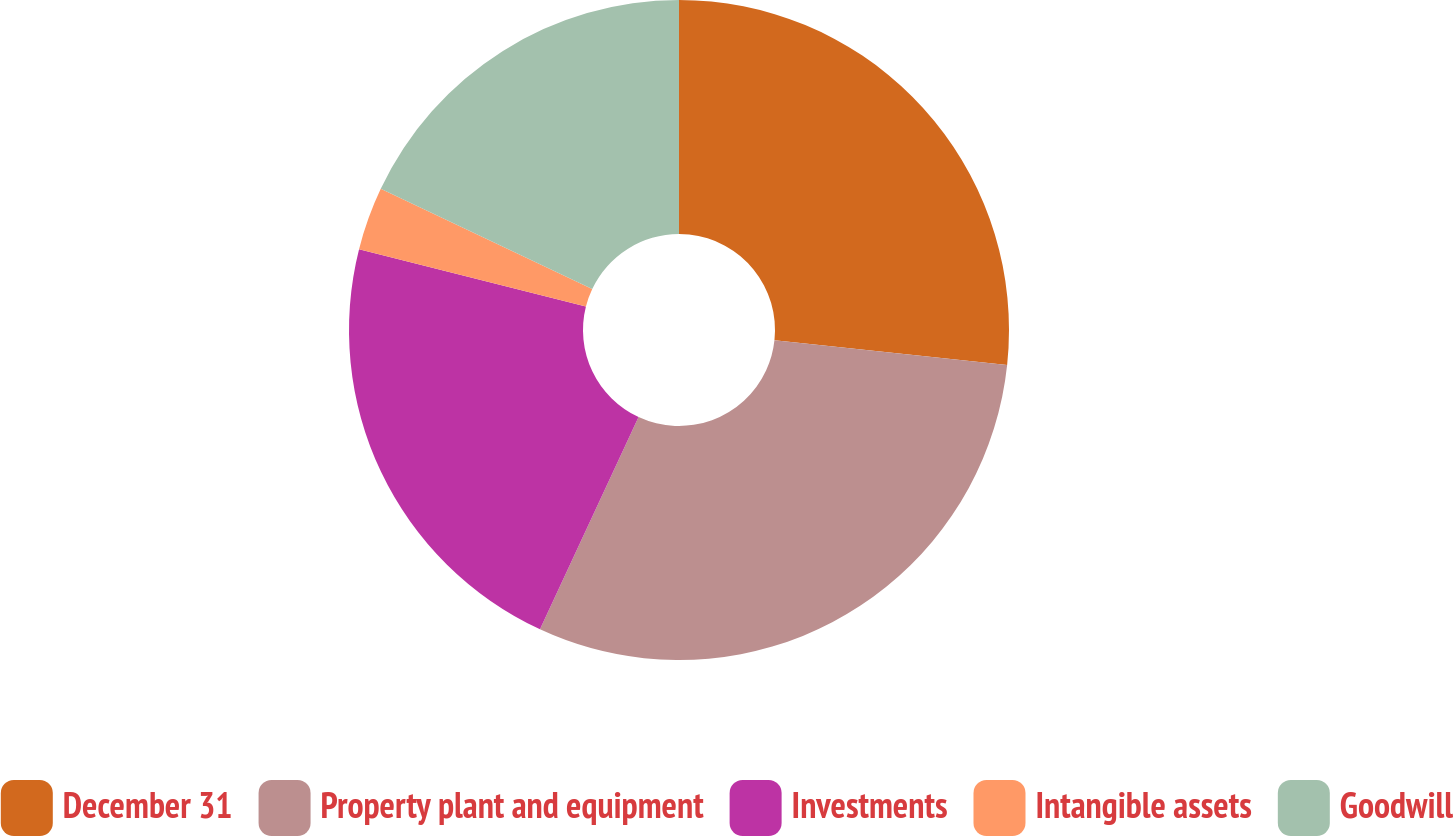Convert chart to OTSL. <chart><loc_0><loc_0><loc_500><loc_500><pie_chart><fcel>December 31<fcel>Property plant and equipment<fcel>Investments<fcel>Intangible assets<fcel>Goodwill<nl><fcel>26.69%<fcel>30.23%<fcel>22.02%<fcel>3.1%<fcel>17.96%<nl></chart> 